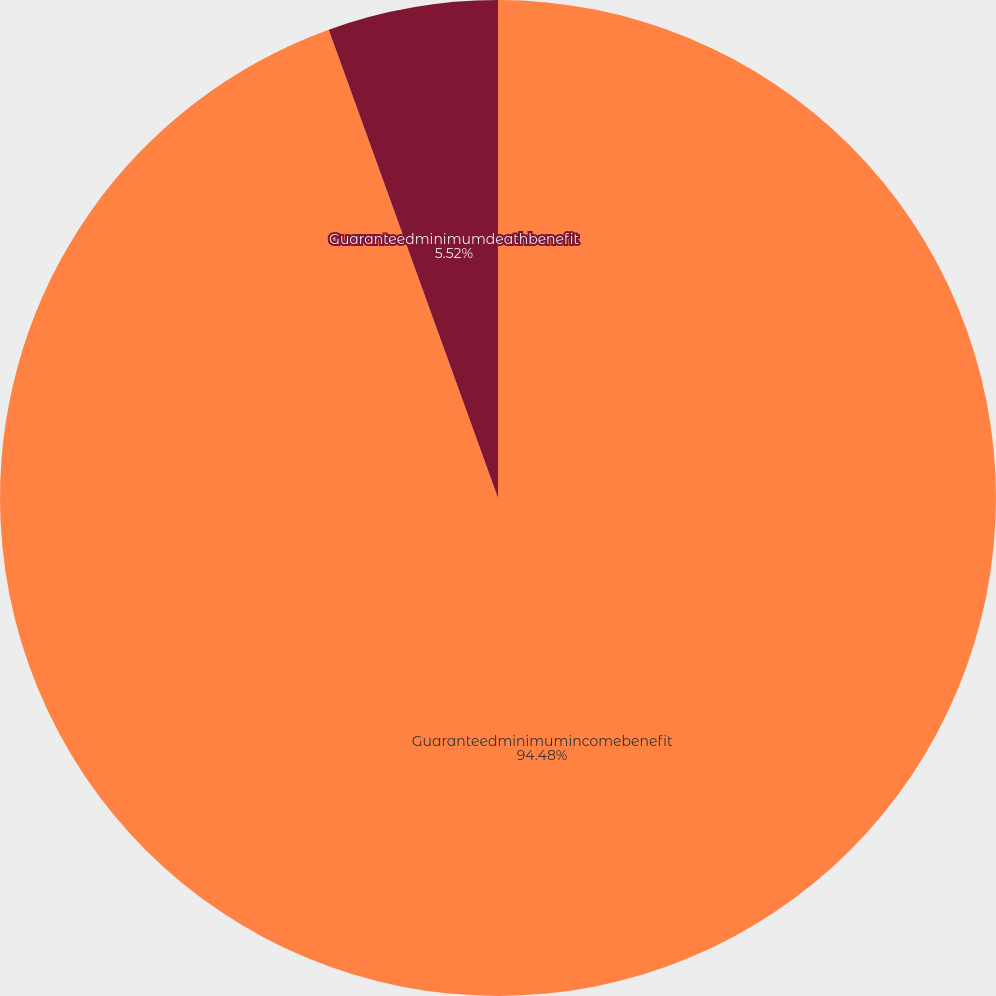Convert chart to OTSL. <chart><loc_0><loc_0><loc_500><loc_500><pie_chart><fcel>Guaranteedminimumincomebenefit<fcel>Guaranteedminimumdeathbenefit<nl><fcel>94.48%<fcel>5.52%<nl></chart> 